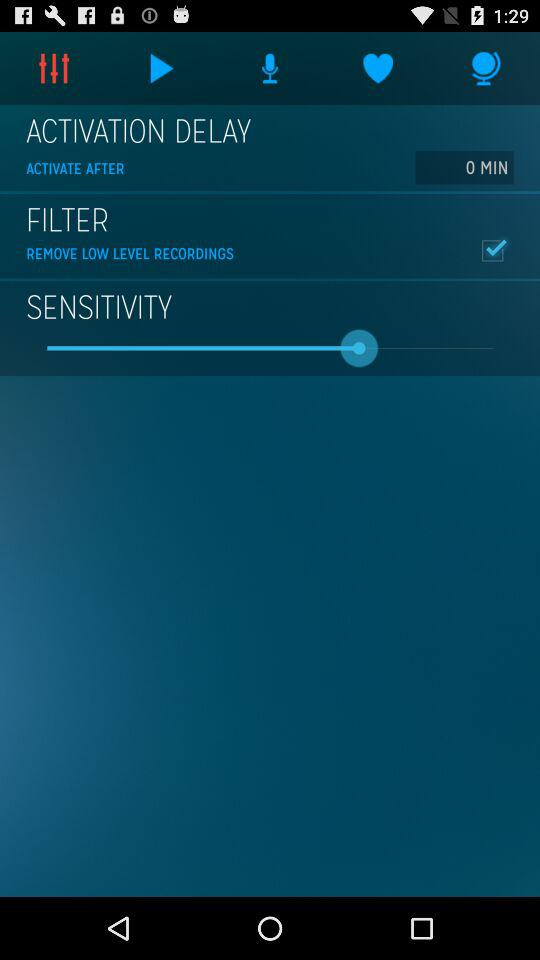Which filter is used? The filter used is "REMOVE LOW LEVEL RECORDINGS". 